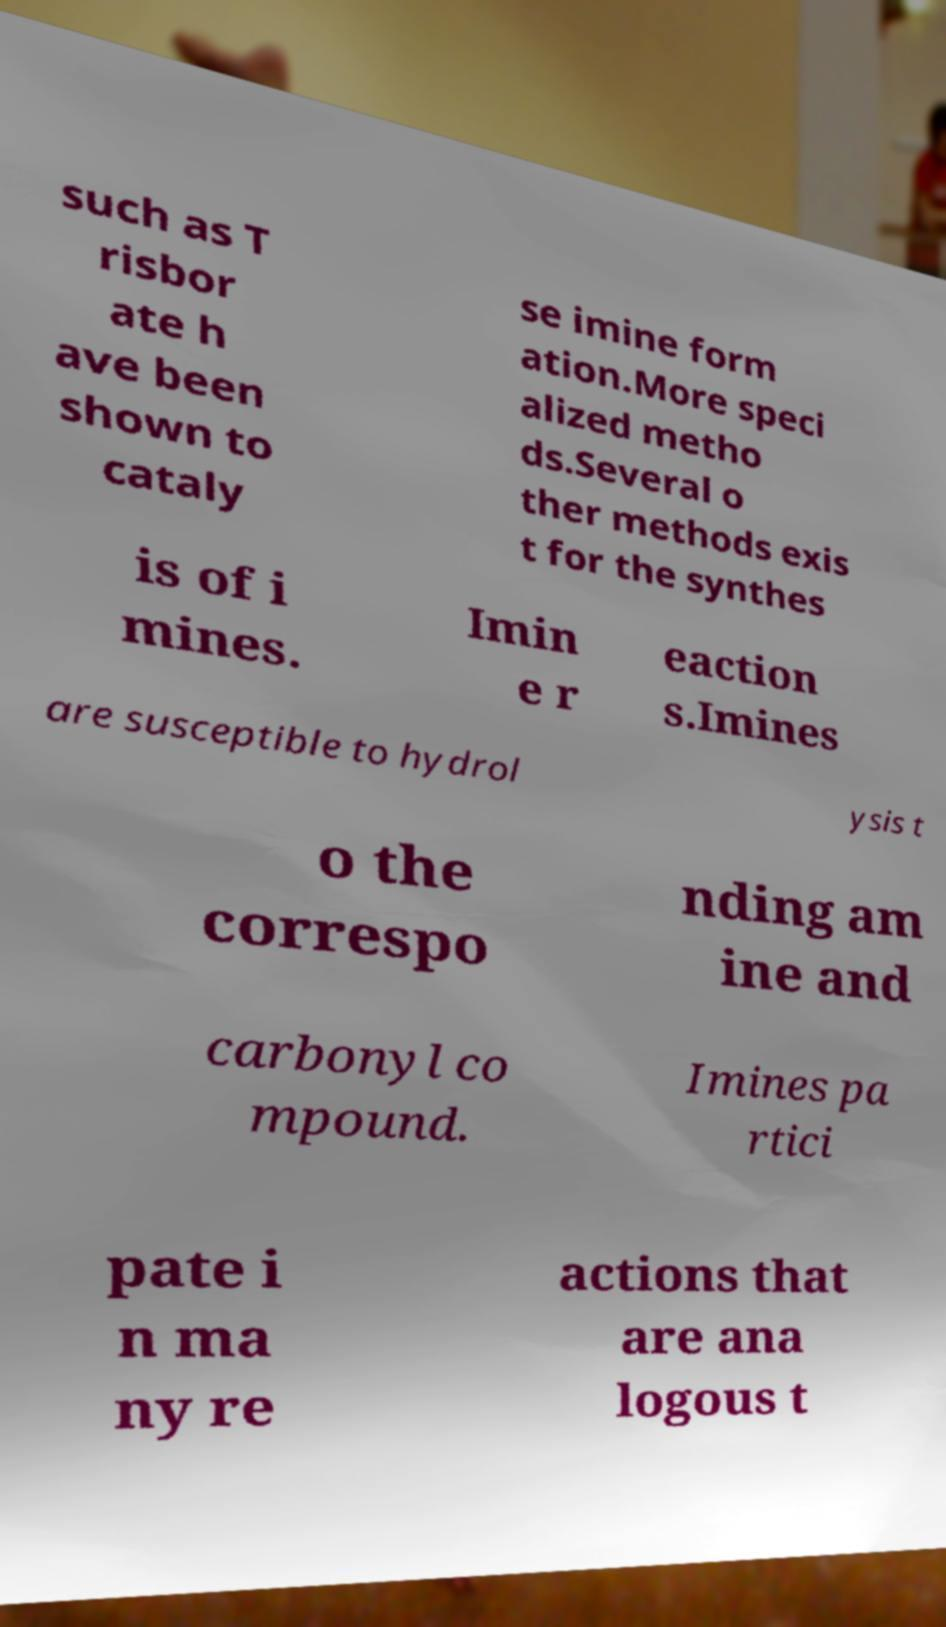For documentation purposes, I need the text within this image transcribed. Could you provide that? such as T risbor ate h ave been shown to cataly se imine form ation.More speci alized metho ds.Several o ther methods exis t for the synthes is of i mines. Imin e r eaction s.Imines are susceptible to hydrol ysis t o the correspo nding am ine and carbonyl co mpound. Imines pa rtici pate i n ma ny re actions that are ana logous t 